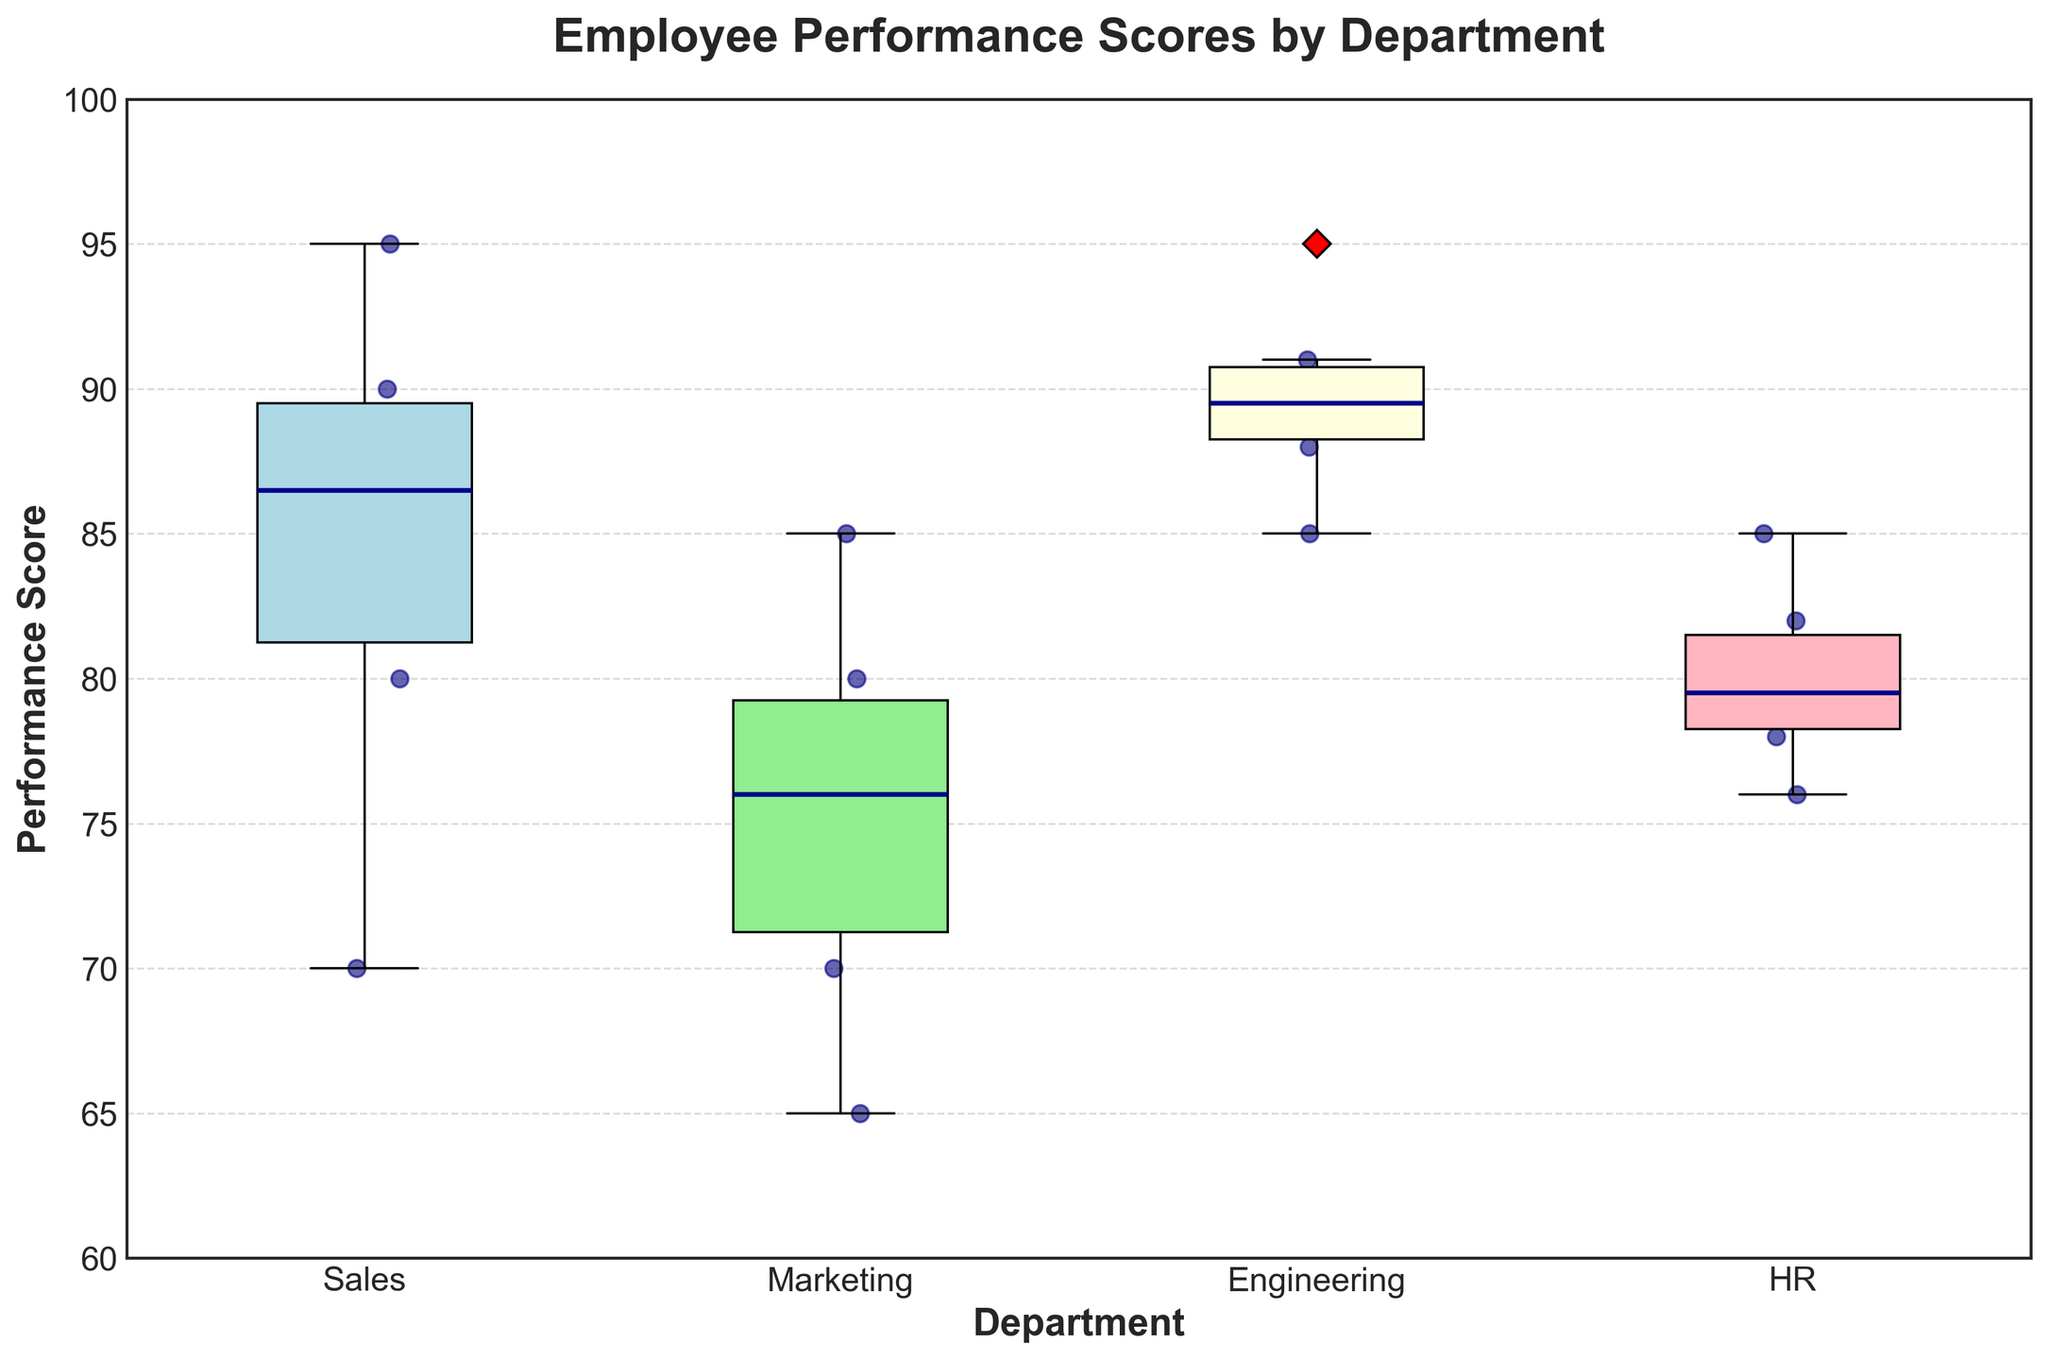What is the title of the plot? The title of the plot can be found at the top center of the plot in larger font size. The provided code specifies the title as 'Employee Performance Scores by Department.'
Answer: Employee Performance Scores by Department What is the range of the y-axis? The range of the y-axis can be observed by looking at the scale on the left side of the plot. The y-axis starts at 60 and ends at 100 as the provided code limits it to that range.
Answer: 60 to 100 Which department has the highest median performance score? The median of a box plot is indicated by the line inside the box. Comparing the boxes, the Engineering department has the line positioned at the highest value compared to other departments.
Answer: Engineering Which department shows the widest spread of performance scores? The spread of scores within a department is indicated by the length of the box and the lines (whiskers) extending from it. The Sales department has the widest spread from the minimum to the maximum score.
Answer: Sales How does the average performance score of the Sales department compare to the Engineering department? To find the averages, observe the scores clustered around the central portions of each box. The Engineering department has higher concentrated scores around its median, while Sales has a wider spread with lower outliers, suggesting a higher average for Engineering.
Answer: Engineering has a higher average score What is the lowest performance score recorded in any department? The lowest performance score can be observed at the bottom whisker of the box plot. This value appears to be slightly above 60 for the Marketing department.
Answer: Slightly above 60 Are there any outliers in the HR department? Outliers in a box plot are represented by individual points outside the whiskers. The HR department has no individual points outside its whiskers, indicating there are no outliers.
Answer: No Compare the interquartile range of Marketing and HR departments. The interquartile range (IQR) is the distance between the top and bottom edges of the box. The HR department's box is taller than Marketing's, indicating a larger IQR for HR.
Answer: HR has a larger IQR 